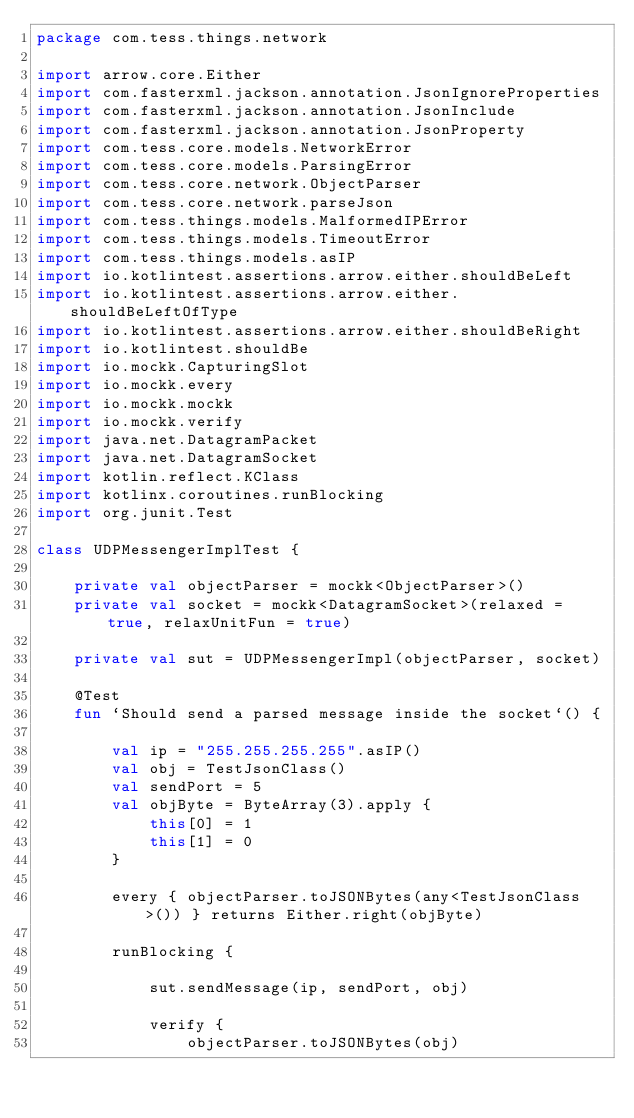<code> <loc_0><loc_0><loc_500><loc_500><_Kotlin_>package com.tess.things.network

import arrow.core.Either
import com.fasterxml.jackson.annotation.JsonIgnoreProperties
import com.fasterxml.jackson.annotation.JsonInclude
import com.fasterxml.jackson.annotation.JsonProperty
import com.tess.core.models.NetworkError
import com.tess.core.models.ParsingError
import com.tess.core.network.ObjectParser
import com.tess.core.network.parseJson
import com.tess.things.models.MalformedIPError
import com.tess.things.models.TimeoutError
import com.tess.things.models.asIP
import io.kotlintest.assertions.arrow.either.shouldBeLeft
import io.kotlintest.assertions.arrow.either.shouldBeLeftOfType
import io.kotlintest.assertions.arrow.either.shouldBeRight
import io.kotlintest.shouldBe
import io.mockk.CapturingSlot
import io.mockk.every
import io.mockk.mockk
import io.mockk.verify
import java.net.DatagramPacket
import java.net.DatagramSocket
import kotlin.reflect.KClass
import kotlinx.coroutines.runBlocking
import org.junit.Test

class UDPMessengerImplTest {

    private val objectParser = mockk<ObjectParser>()
    private val socket = mockk<DatagramSocket>(relaxed = true, relaxUnitFun = true)

    private val sut = UDPMessengerImpl(objectParser, socket)

    @Test
    fun `Should send a parsed message inside the socket`() {

        val ip = "255.255.255.255".asIP()
        val obj = TestJsonClass()
        val sendPort = 5
        val objByte = ByteArray(3).apply {
            this[0] = 1
            this[1] = 0
        }

        every { objectParser.toJSONBytes(any<TestJsonClass>()) } returns Either.right(objByte)

        runBlocking {

            sut.sendMessage(ip, sendPort, obj)

            verify {
                objectParser.toJSONBytes(obj)</code> 